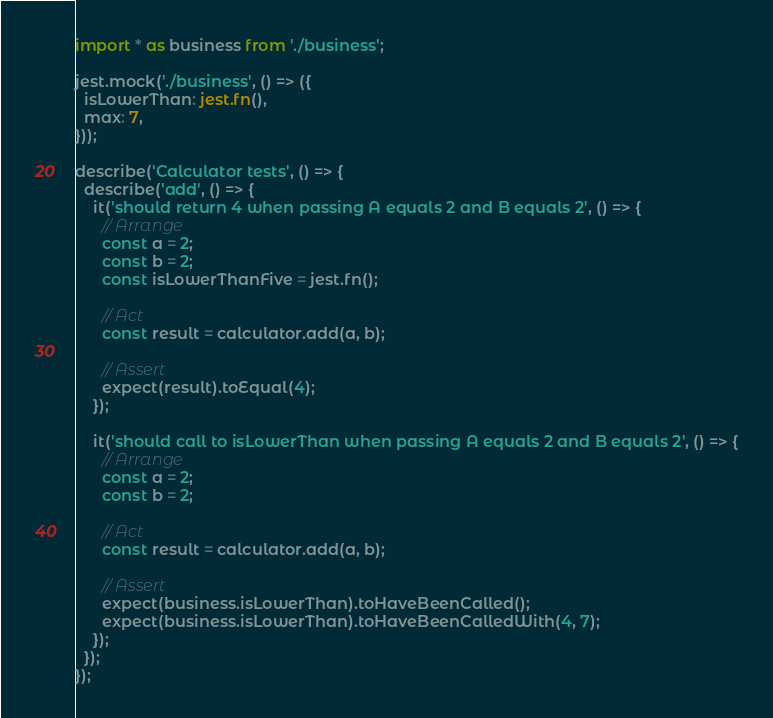<code> <loc_0><loc_0><loc_500><loc_500><_TypeScript_>import * as business from './business';

jest.mock('./business', () => ({
  isLowerThan: jest.fn(),
  max: 7,
}));

describe('Calculator tests', () => {
  describe('add', () => {
    it('should return 4 when passing A equals 2 and B equals 2', () => {
      // Arrange
      const a = 2;
      const b = 2;
      const isLowerThanFive = jest.fn();

      // Act
      const result = calculator.add(a, b);

      // Assert
      expect(result).toEqual(4);
    });

    it('should call to isLowerThan when passing A equals 2 and B equals 2', () => {
      // Arrange
      const a = 2;
      const b = 2;

      // Act
      const result = calculator.add(a, b);

      // Assert
      expect(business.isLowerThan).toHaveBeenCalled();
      expect(business.isLowerThan).toHaveBeenCalledWith(4, 7);
    });
  });
});
</code> 